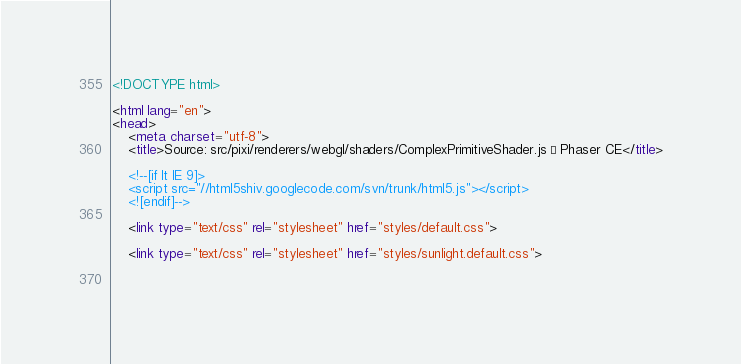<code> <loc_0><loc_0><loc_500><loc_500><_HTML_><!DOCTYPE html>

<html lang="en">
<head>
	<meta charset="utf-8">
	<title>Source: src/pixi/renderers/webgl/shaders/ComplexPrimitiveShader.js · Phaser CE</title>

	<!--[if lt IE 9]>
	<script src="//html5shiv.googlecode.com/svn/trunk/html5.js"></script>
	<![endif]-->

	<link type="text/css" rel="stylesheet" href="styles/default.css">

	<link type="text/css" rel="stylesheet" href="styles/sunlight.default.css">

	</code> 